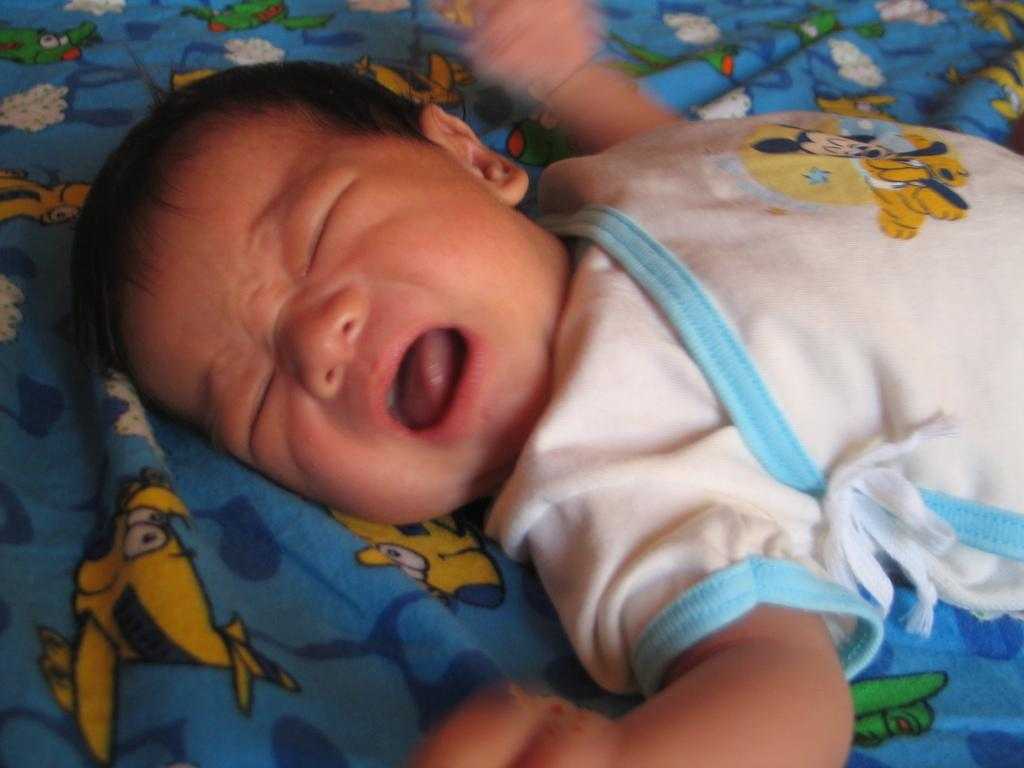What is the main subject of the image? The main subject of the image is a baby. What is the baby lying on? The baby is lying on a cloth. What is depicted on the cloth? The cloth has animated characters on it. How many tomatoes are visible in the image? There are no tomatoes present in the image. Is there a beggar standing near the baby in the image? There is no beggar present in the image. How many chairs are visible in the image? There are no chairs present in the image. 